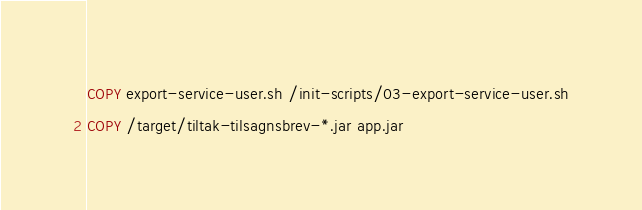<code> <loc_0><loc_0><loc_500><loc_500><_Dockerfile_>COPY export-service-user.sh /init-scripts/03-export-service-user.sh
COPY /target/tiltak-tilsagnsbrev-*.jar app.jar</code> 